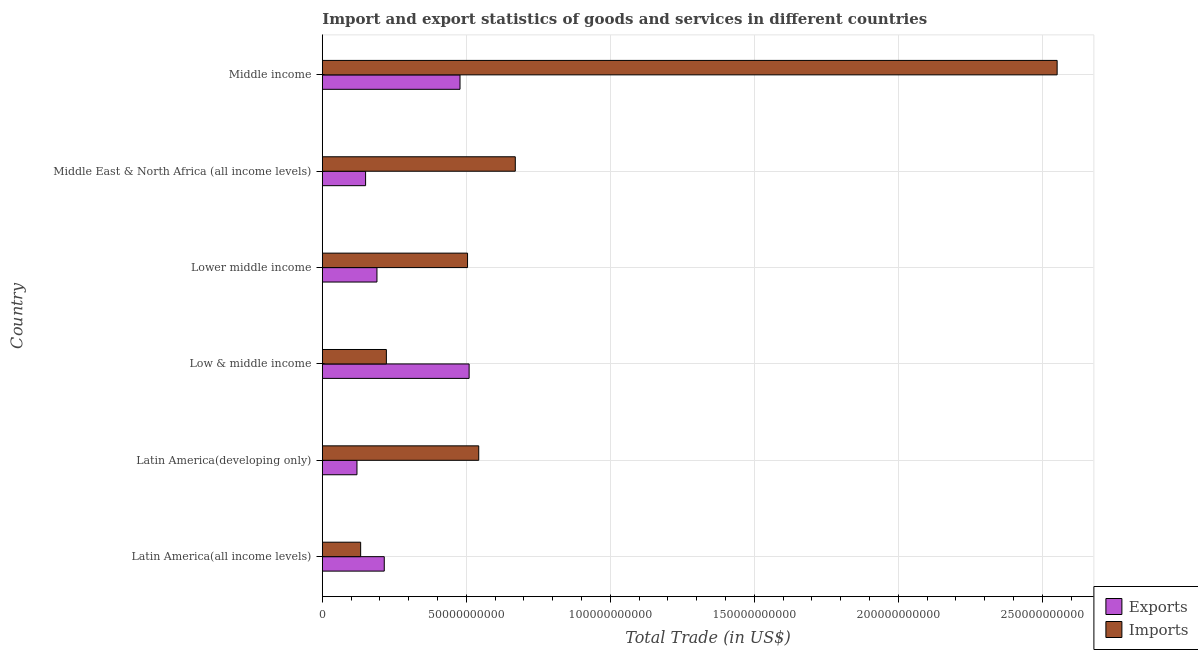How many bars are there on the 4th tick from the bottom?
Your answer should be very brief. 2. What is the label of the 2nd group of bars from the top?
Make the answer very short. Middle East & North Africa (all income levels). What is the export of goods and services in Middle East & North Africa (all income levels)?
Provide a short and direct response. 1.50e+1. Across all countries, what is the maximum imports of goods and services?
Give a very brief answer. 2.55e+11. Across all countries, what is the minimum imports of goods and services?
Give a very brief answer. 1.33e+1. In which country was the export of goods and services minimum?
Give a very brief answer. Latin America(developing only). What is the total imports of goods and services in the graph?
Provide a succinct answer. 4.62e+11. What is the difference between the export of goods and services in Low & middle income and that in Middle income?
Offer a terse response. 3.16e+09. What is the difference between the export of goods and services in Middle income and the imports of goods and services in Latin America(all income levels)?
Offer a terse response. 3.45e+1. What is the average export of goods and services per country?
Keep it short and to the point. 2.77e+1. What is the difference between the export of goods and services and imports of goods and services in Middle East & North Africa (all income levels)?
Provide a short and direct response. -5.20e+1. In how many countries, is the export of goods and services greater than 230000000000 US$?
Make the answer very short. 0. What is the ratio of the export of goods and services in Latin America(all income levels) to that in Middle East & North Africa (all income levels)?
Give a very brief answer. 1.43. Is the imports of goods and services in Lower middle income less than that in Middle East & North Africa (all income levels)?
Your answer should be compact. Yes. Is the difference between the export of goods and services in Latin America(all income levels) and Lower middle income greater than the difference between the imports of goods and services in Latin America(all income levels) and Lower middle income?
Make the answer very short. Yes. What is the difference between the highest and the second highest export of goods and services?
Provide a succinct answer. 3.16e+09. What is the difference between the highest and the lowest imports of goods and services?
Offer a very short reply. 2.42e+11. What does the 1st bar from the top in Middle income represents?
Your answer should be very brief. Imports. What does the 1st bar from the bottom in Lower middle income represents?
Give a very brief answer. Exports. Where does the legend appear in the graph?
Provide a short and direct response. Bottom right. How many legend labels are there?
Your answer should be very brief. 2. How are the legend labels stacked?
Offer a very short reply. Vertical. What is the title of the graph?
Give a very brief answer. Import and export statistics of goods and services in different countries. Does "Travel Items" appear as one of the legend labels in the graph?
Make the answer very short. No. What is the label or title of the X-axis?
Your answer should be compact. Total Trade (in US$). What is the label or title of the Y-axis?
Offer a terse response. Country. What is the Total Trade (in US$) of Exports in Latin America(all income levels)?
Your response must be concise. 2.15e+1. What is the Total Trade (in US$) of Imports in Latin America(all income levels)?
Offer a terse response. 1.33e+1. What is the Total Trade (in US$) of Exports in Latin America(developing only)?
Offer a very short reply. 1.20e+1. What is the Total Trade (in US$) in Imports in Latin America(developing only)?
Make the answer very short. 5.43e+1. What is the Total Trade (in US$) of Exports in Low & middle income?
Ensure brevity in your answer.  5.10e+1. What is the Total Trade (in US$) of Imports in Low & middle income?
Your answer should be compact. 2.22e+1. What is the Total Trade (in US$) in Exports in Lower middle income?
Ensure brevity in your answer.  1.90e+1. What is the Total Trade (in US$) of Imports in Lower middle income?
Keep it short and to the point. 5.04e+1. What is the Total Trade (in US$) in Exports in Middle East & North Africa (all income levels)?
Ensure brevity in your answer.  1.50e+1. What is the Total Trade (in US$) of Imports in Middle East & North Africa (all income levels)?
Offer a very short reply. 6.70e+1. What is the Total Trade (in US$) in Exports in Middle income?
Give a very brief answer. 4.78e+1. What is the Total Trade (in US$) in Imports in Middle income?
Provide a short and direct response. 2.55e+11. Across all countries, what is the maximum Total Trade (in US$) of Exports?
Give a very brief answer. 5.10e+1. Across all countries, what is the maximum Total Trade (in US$) in Imports?
Make the answer very short. 2.55e+11. Across all countries, what is the minimum Total Trade (in US$) of Exports?
Ensure brevity in your answer.  1.20e+1. Across all countries, what is the minimum Total Trade (in US$) in Imports?
Ensure brevity in your answer.  1.33e+1. What is the total Total Trade (in US$) of Exports in the graph?
Your answer should be compact. 1.66e+11. What is the total Total Trade (in US$) of Imports in the graph?
Your response must be concise. 4.62e+11. What is the difference between the Total Trade (in US$) of Exports in Latin America(all income levels) and that in Latin America(developing only)?
Keep it short and to the point. 9.48e+09. What is the difference between the Total Trade (in US$) in Imports in Latin America(all income levels) and that in Latin America(developing only)?
Your answer should be very brief. -4.10e+1. What is the difference between the Total Trade (in US$) of Exports in Latin America(all income levels) and that in Low & middle income?
Make the answer very short. -2.95e+1. What is the difference between the Total Trade (in US$) in Imports in Latin America(all income levels) and that in Low & middle income?
Offer a terse response. -8.93e+09. What is the difference between the Total Trade (in US$) in Exports in Latin America(all income levels) and that in Lower middle income?
Your answer should be very brief. 2.54e+09. What is the difference between the Total Trade (in US$) in Imports in Latin America(all income levels) and that in Lower middle income?
Offer a very short reply. -3.71e+1. What is the difference between the Total Trade (in US$) of Exports in Latin America(all income levels) and that in Middle East & North Africa (all income levels)?
Offer a terse response. 6.48e+09. What is the difference between the Total Trade (in US$) in Imports in Latin America(all income levels) and that in Middle East & North Africa (all income levels)?
Keep it short and to the point. -5.37e+1. What is the difference between the Total Trade (in US$) in Exports in Latin America(all income levels) and that in Middle income?
Give a very brief answer. -2.63e+1. What is the difference between the Total Trade (in US$) of Imports in Latin America(all income levels) and that in Middle income?
Make the answer very short. -2.42e+11. What is the difference between the Total Trade (in US$) of Exports in Latin America(developing only) and that in Low & middle income?
Keep it short and to the point. -3.89e+1. What is the difference between the Total Trade (in US$) of Imports in Latin America(developing only) and that in Low & middle income?
Give a very brief answer. 3.21e+1. What is the difference between the Total Trade (in US$) of Exports in Latin America(developing only) and that in Lower middle income?
Your response must be concise. -6.94e+09. What is the difference between the Total Trade (in US$) of Imports in Latin America(developing only) and that in Lower middle income?
Offer a very short reply. 3.89e+09. What is the difference between the Total Trade (in US$) in Exports in Latin America(developing only) and that in Middle East & North Africa (all income levels)?
Your answer should be compact. -2.99e+09. What is the difference between the Total Trade (in US$) in Imports in Latin America(developing only) and that in Middle East & North Africa (all income levels)?
Offer a terse response. -1.27e+1. What is the difference between the Total Trade (in US$) in Exports in Latin America(developing only) and that in Middle income?
Provide a succinct answer. -3.58e+1. What is the difference between the Total Trade (in US$) of Imports in Latin America(developing only) and that in Middle income?
Ensure brevity in your answer.  -2.01e+11. What is the difference between the Total Trade (in US$) in Exports in Low & middle income and that in Lower middle income?
Your response must be concise. 3.20e+1. What is the difference between the Total Trade (in US$) in Imports in Low & middle income and that in Lower middle income?
Offer a very short reply. -2.82e+1. What is the difference between the Total Trade (in US$) in Exports in Low & middle income and that in Middle East & North Africa (all income levels)?
Your answer should be compact. 3.59e+1. What is the difference between the Total Trade (in US$) of Imports in Low & middle income and that in Middle East & North Africa (all income levels)?
Give a very brief answer. -4.48e+1. What is the difference between the Total Trade (in US$) of Exports in Low & middle income and that in Middle income?
Ensure brevity in your answer.  3.16e+09. What is the difference between the Total Trade (in US$) of Imports in Low & middle income and that in Middle income?
Make the answer very short. -2.33e+11. What is the difference between the Total Trade (in US$) of Exports in Lower middle income and that in Middle East & North Africa (all income levels)?
Provide a short and direct response. 3.94e+09. What is the difference between the Total Trade (in US$) in Imports in Lower middle income and that in Middle East & North Africa (all income levels)?
Offer a terse response. -1.66e+1. What is the difference between the Total Trade (in US$) in Exports in Lower middle income and that in Middle income?
Your answer should be compact. -2.88e+1. What is the difference between the Total Trade (in US$) in Imports in Lower middle income and that in Middle income?
Your response must be concise. -2.05e+11. What is the difference between the Total Trade (in US$) in Exports in Middle East & North Africa (all income levels) and that in Middle income?
Keep it short and to the point. -3.28e+1. What is the difference between the Total Trade (in US$) of Imports in Middle East & North Africa (all income levels) and that in Middle income?
Your answer should be compact. -1.88e+11. What is the difference between the Total Trade (in US$) in Exports in Latin America(all income levels) and the Total Trade (in US$) in Imports in Latin America(developing only)?
Offer a very short reply. -3.28e+1. What is the difference between the Total Trade (in US$) in Exports in Latin America(all income levels) and the Total Trade (in US$) in Imports in Low & middle income?
Your answer should be compact. -7.33e+08. What is the difference between the Total Trade (in US$) of Exports in Latin America(all income levels) and the Total Trade (in US$) of Imports in Lower middle income?
Your answer should be very brief. -2.89e+1. What is the difference between the Total Trade (in US$) in Exports in Latin America(all income levels) and the Total Trade (in US$) in Imports in Middle East & North Africa (all income levels)?
Your answer should be compact. -4.55e+1. What is the difference between the Total Trade (in US$) of Exports in Latin America(all income levels) and the Total Trade (in US$) of Imports in Middle income?
Offer a terse response. -2.34e+11. What is the difference between the Total Trade (in US$) in Exports in Latin America(developing only) and the Total Trade (in US$) in Imports in Low & middle income?
Give a very brief answer. -1.02e+1. What is the difference between the Total Trade (in US$) of Exports in Latin America(developing only) and the Total Trade (in US$) of Imports in Lower middle income?
Your answer should be very brief. -3.84e+1. What is the difference between the Total Trade (in US$) of Exports in Latin America(developing only) and the Total Trade (in US$) of Imports in Middle East & North Africa (all income levels)?
Offer a very short reply. -5.50e+1. What is the difference between the Total Trade (in US$) of Exports in Latin America(developing only) and the Total Trade (in US$) of Imports in Middle income?
Offer a terse response. -2.43e+11. What is the difference between the Total Trade (in US$) in Exports in Low & middle income and the Total Trade (in US$) in Imports in Lower middle income?
Provide a succinct answer. 5.49e+08. What is the difference between the Total Trade (in US$) in Exports in Low & middle income and the Total Trade (in US$) in Imports in Middle East & North Africa (all income levels)?
Your answer should be compact. -1.60e+1. What is the difference between the Total Trade (in US$) in Exports in Low & middle income and the Total Trade (in US$) in Imports in Middle income?
Your answer should be compact. -2.04e+11. What is the difference between the Total Trade (in US$) in Exports in Lower middle income and the Total Trade (in US$) in Imports in Middle East & North Africa (all income levels)?
Ensure brevity in your answer.  -4.80e+1. What is the difference between the Total Trade (in US$) of Exports in Lower middle income and the Total Trade (in US$) of Imports in Middle income?
Ensure brevity in your answer.  -2.36e+11. What is the difference between the Total Trade (in US$) in Exports in Middle East & North Africa (all income levels) and the Total Trade (in US$) in Imports in Middle income?
Offer a very short reply. -2.40e+11. What is the average Total Trade (in US$) of Exports per country?
Offer a very short reply. 2.77e+1. What is the average Total Trade (in US$) in Imports per country?
Offer a very short reply. 7.71e+1. What is the difference between the Total Trade (in US$) of Exports and Total Trade (in US$) of Imports in Latin America(all income levels)?
Your answer should be compact. 8.20e+09. What is the difference between the Total Trade (in US$) of Exports and Total Trade (in US$) of Imports in Latin America(developing only)?
Provide a short and direct response. -4.23e+1. What is the difference between the Total Trade (in US$) in Exports and Total Trade (in US$) in Imports in Low & middle income?
Provide a short and direct response. 2.87e+1. What is the difference between the Total Trade (in US$) in Exports and Total Trade (in US$) in Imports in Lower middle income?
Make the answer very short. -3.15e+1. What is the difference between the Total Trade (in US$) in Exports and Total Trade (in US$) in Imports in Middle East & North Africa (all income levels)?
Make the answer very short. -5.20e+1. What is the difference between the Total Trade (in US$) of Exports and Total Trade (in US$) of Imports in Middle income?
Offer a terse response. -2.07e+11. What is the ratio of the Total Trade (in US$) of Exports in Latin America(all income levels) to that in Latin America(developing only)?
Give a very brief answer. 1.79. What is the ratio of the Total Trade (in US$) in Imports in Latin America(all income levels) to that in Latin America(developing only)?
Provide a short and direct response. 0.25. What is the ratio of the Total Trade (in US$) in Exports in Latin America(all income levels) to that in Low & middle income?
Offer a very short reply. 0.42. What is the ratio of the Total Trade (in US$) of Imports in Latin America(all income levels) to that in Low & middle income?
Ensure brevity in your answer.  0.6. What is the ratio of the Total Trade (in US$) in Exports in Latin America(all income levels) to that in Lower middle income?
Provide a short and direct response. 1.13. What is the ratio of the Total Trade (in US$) in Imports in Latin America(all income levels) to that in Lower middle income?
Your answer should be very brief. 0.26. What is the ratio of the Total Trade (in US$) in Exports in Latin America(all income levels) to that in Middle East & North Africa (all income levels)?
Ensure brevity in your answer.  1.43. What is the ratio of the Total Trade (in US$) of Imports in Latin America(all income levels) to that in Middle East & North Africa (all income levels)?
Provide a short and direct response. 0.2. What is the ratio of the Total Trade (in US$) of Exports in Latin America(all income levels) to that in Middle income?
Ensure brevity in your answer.  0.45. What is the ratio of the Total Trade (in US$) in Imports in Latin America(all income levels) to that in Middle income?
Your answer should be very brief. 0.05. What is the ratio of the Total Trade (in US$) of Exports in Latin America(developing only) to that in Low & middle income?
Give a very brief answer. 0.24. What is the ratio of the Total Trade (in US$) of Imports in Latin America(developing only) to that in Low & middle income?
Your answer should be compact. 2.44. What is the ratio of the Total Trade (in US$) in Exports in Latin America(developing only) to that in Lower middle income?
Your response must be concise. 0.63. What is the ratio of the Total Trade (in US$) of Imports in Latin America(developing only) to that in Lower middle income?
Provide a succinct answer. 1.08. What is the ratio of the Total Trade (in US$) in Exports in Latin America(developing only) to that in Middle East & North Africa (all income levels)?
Give a very brief answer. 0.8. What is the ratio of the Total Trade (in US$) of Imports in Latin America(developing only) to that in Middle East & North Africa (all income levels)?
Make the answer very short. 0.81. What is the ratio of the Total Trade (in US$) in Exports in Latin America(developing only) to that in Middle income?
Provide a short and direct response. 0.25. What is the ratio of the Total Trade (in US$) of Imports in Latin America(developing only) to that in Middle income?
Offer a terse response. 0.21. What is the ratio of the Total Trade (in US$) in Exports in Low & middle income to that in Lower middle income?
Your response must be concise. 2.69. What is the ratio of the Total Trade (in US$) of Imports in Low & middle income to that in Lower middle income?
Your answer should be compact. 0.44. What is the ratio of the Total Trade (in US$) of Exports in Low & middle income to that in Middle East & North Africa (all income levels)?
Provide a short and direct response. 3.39. What is the ratio of the Total Trade (in US$) of Imports in Low & middle income to that in Middle East & North Africa (all income levels)?
Keep it short and to the point. 0.33. What is the ratio of the Total Trade (in US$) in Exports in Low & middle income to that in Middle income?
Your response must be concise. 1.07. What is the ratio of the Total Trade (in US$) of Imports in Low & middle income to that in Middle income?
Offer a very short reply. 0.09. What is the ratio of the Total Trade (in US$) of Exports in Lower middle income to that in Middle East & North Africa (all income levels)?
Offer a terse response. 1.26. What is the ratio of the Total Trade (in US$) of Imports in Lower middle income to that in Middle East & North Africa (all income levels)?
Give a very brief answer. 0.75. What is the ratio of the Total Trade (in US$) of Exports in Lower middle income to that in Middle income?
Your answer should be very brief. 0.4. What is the ratio of the Total Trade (in US$) in Imports in Lower middle income to that in Middle income?
Offer a terse response. 0.2. What is the ratio of the Total Trade (in US$) in Exports in Middle East & North Africa (all income levels) to that in Middle income?
Keep it short and to the point. 0.31. What is the ratio of the Total Trade (in US$) of Imports in Middle East & North Africa (all income levels) to that in Middle income?
Your answer should be compact. 0.26. What is the difference between the highest and the second highest Total Trade (in US$) in Exports?
Offer a terse response. 3.16e+09. What is the difference between the highest and the second highest Total Trade (in US$) in Imports?
Offer a terse response. 1.88e+11. What is the difference between the highest and the lowest Total Trade (in US$) of Exports?
Offer a very short reply. 3.89e+1. What is the difference between the highest and the lowest Total Trade (in US$) of Imports?
Your answer should be compact. 2.42e+11. 